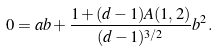Convert formula to latex. <formula><loc_0><loc_0><loc_500><loc_500>0 = a b + \frac { 1 + ( d - 1 ) A ( 1 , 2 ) } { ( d - 1 ) ^ { 3 / 2 } } b ^ { 2 } .</formula> 